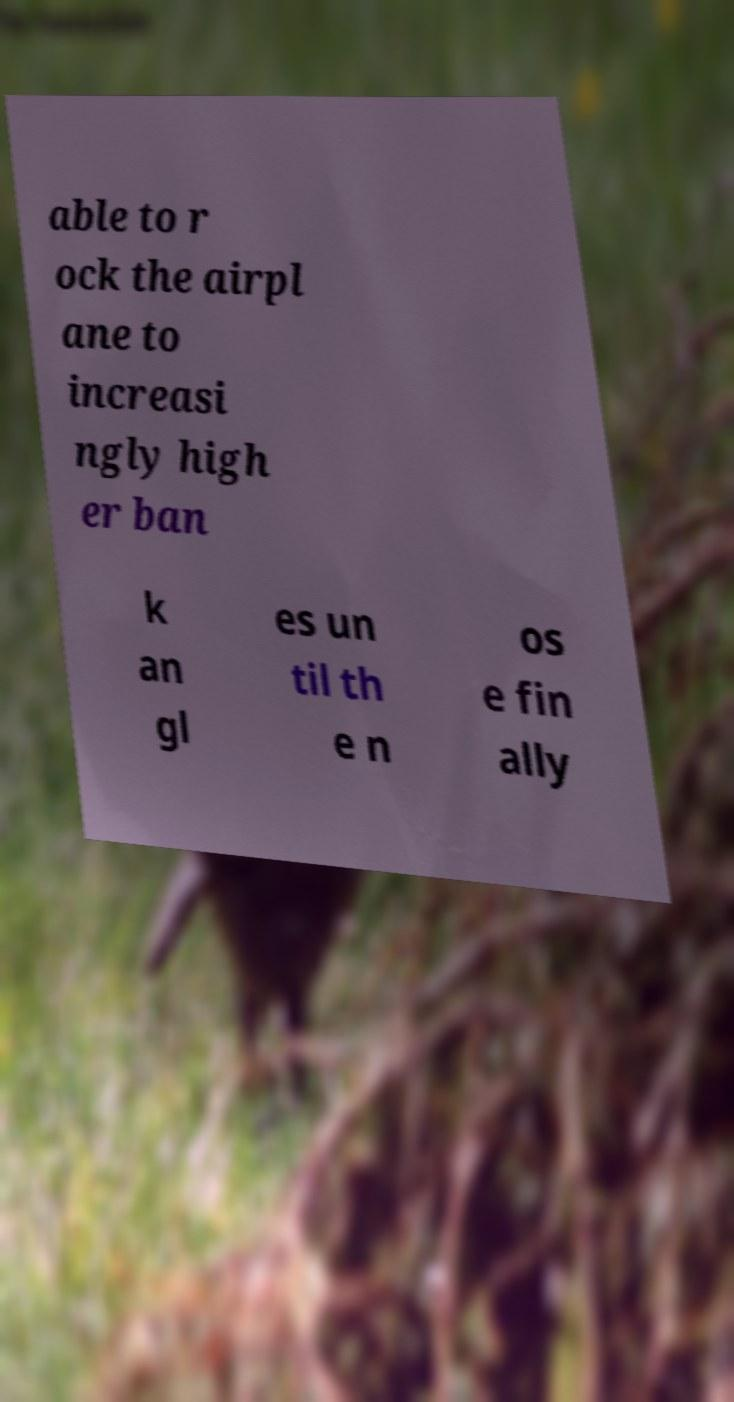Could you assist in decoding the text presented in this image and type it out clearly? able to r ock the airpl ane to increasi ngly high er ban k an gl es un til th e n os e fin ally 